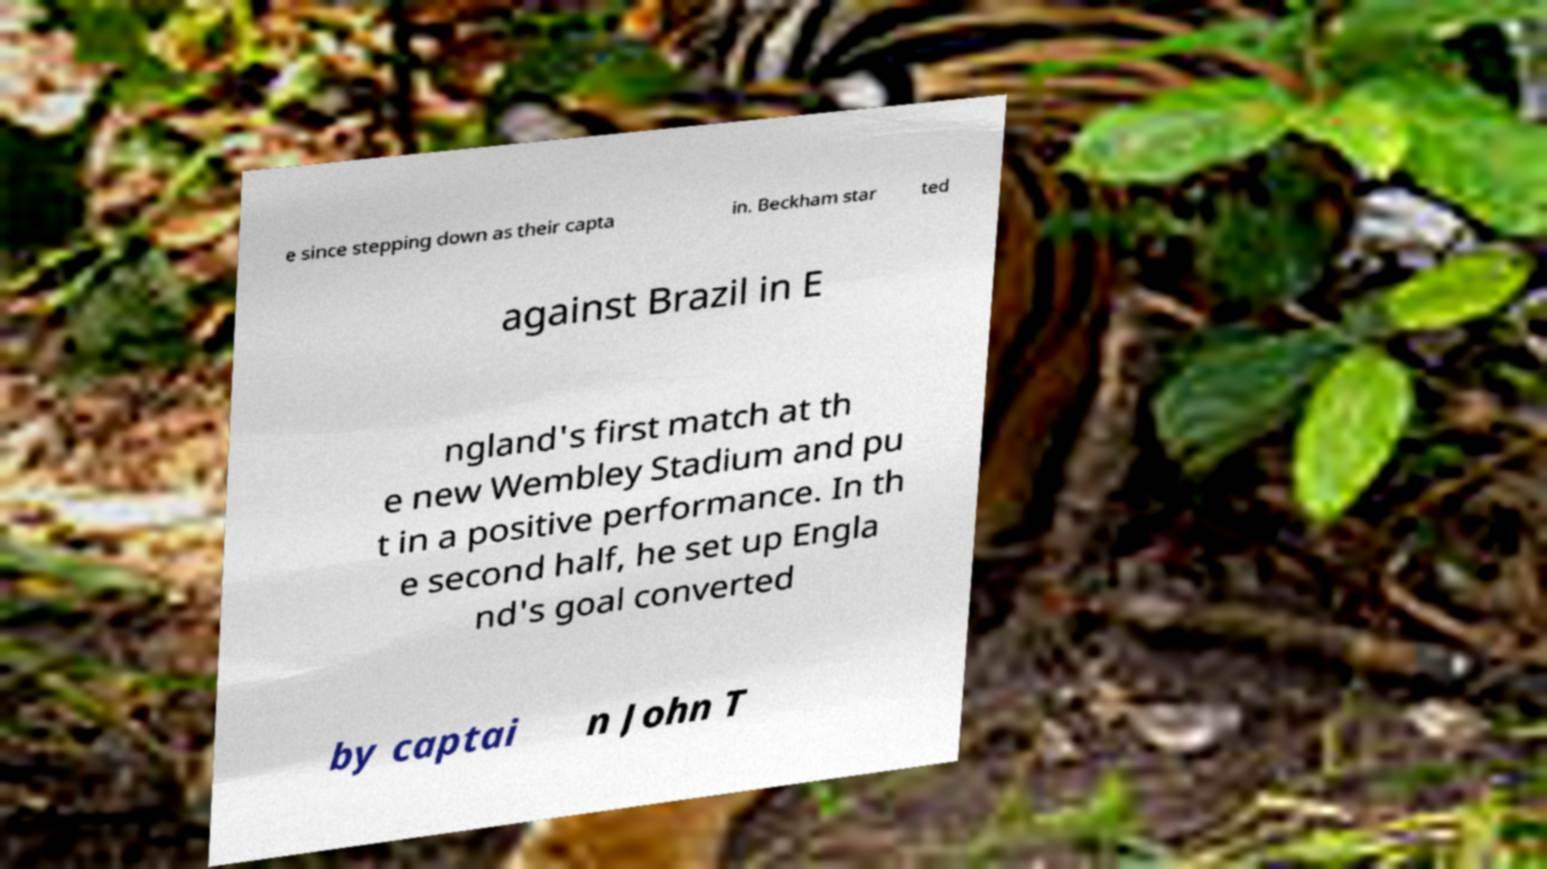For documentation purposes, I need the text within this image transcribed. Could you provide that? e since stepping down as their capta in. Beckham star ted against Brazil in E ngland's first match at th e new Wembley Stadium and pu t in a positive performance. In th e second half, he set up Engla nd's goal converted by captai n John T 